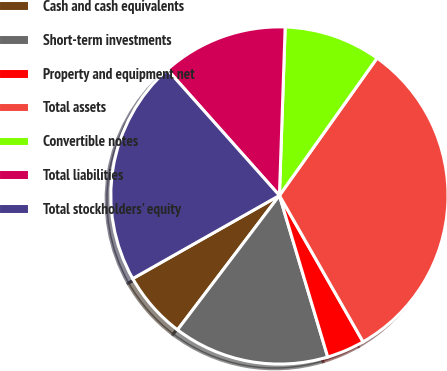Convert chart. <chart><loc_0><loc_0><loc_500><loc_500><pie_chart><fcel>Cash and cash equivalents<fcel>Short-term investments<fcel>Property and equipment net<fcel>Total assets<fcel>Convertible notes<fcel>Total liabilities<fcel>Total stockholders' equity<nl><fcel>6.47%<fcel>14.95%<fcel>3.64%<fcel>31.9%<fcel>9.29%<fcel>12.12%<fcel>21.63%<nl></chart> 